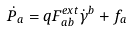Convert formula to latex. <formula><loc_0><loc_0><loc_500><loc_500>\dot { P } _ { a } = q F _ { a b } ^ { e x t } \dot { \gamma } ^ { b } + f _ { a }</formula> 